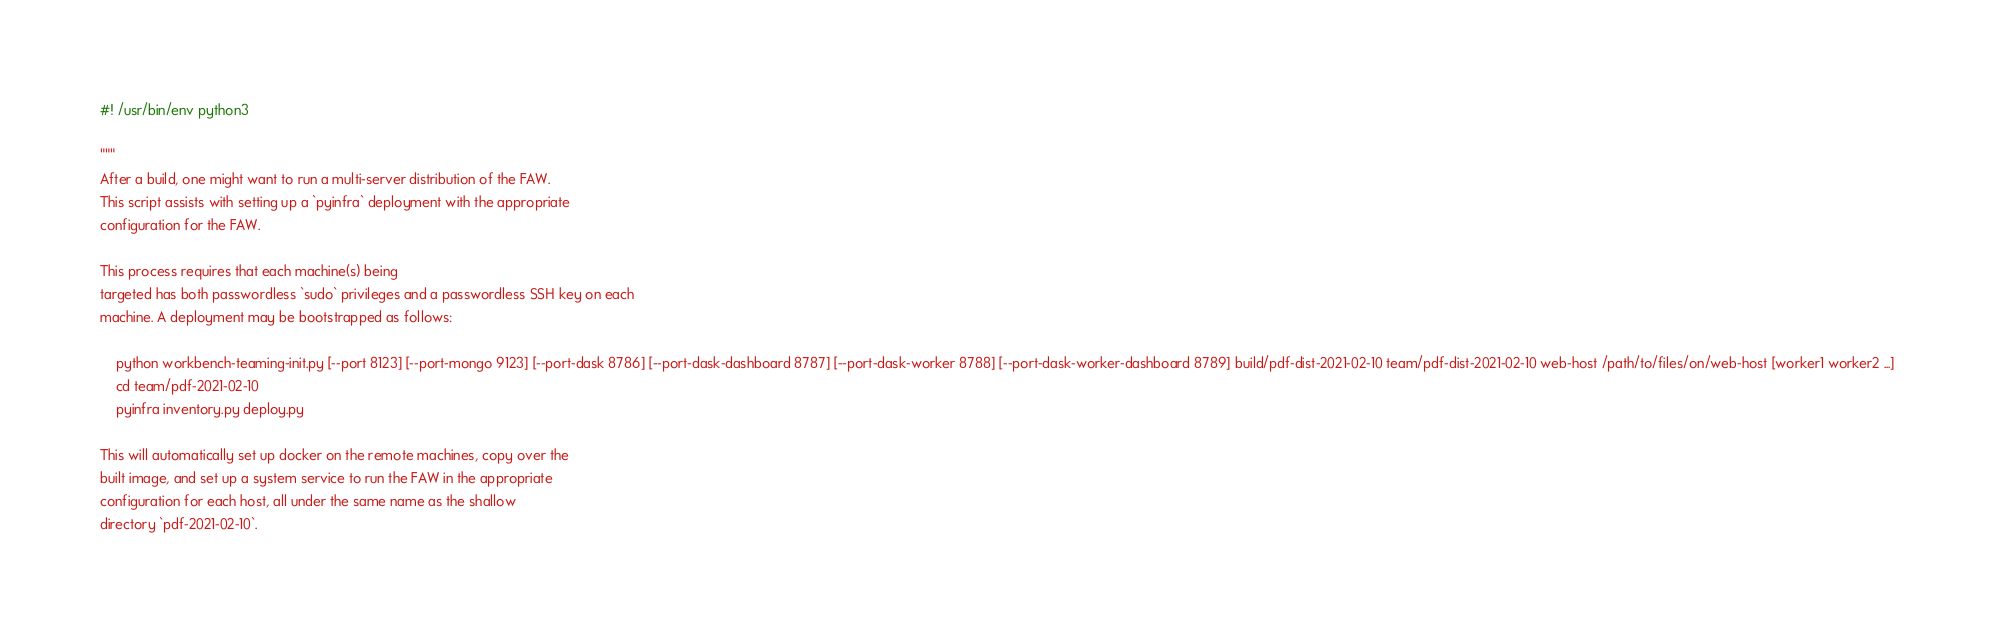Convert code to text. <code><loc_0><loc_0><loc_500><loc_500><_Python_>#! /usr/bin/env python3

"""
After a build, one might want to run a multi-server distribution of the FAW.
This script assists with setting up a `pyinfra` deployment with the appropriate
configuration for the FAW.

This process requires that each machine(s) being
targeted has both passwordless `sudo` privileges and a passwordless SSH key on each
machine. A deployment may be bootstrapped as follows:

    python workbench-teaming-init.py [--port 8123] [--port-mongo 9123] [--port-dask 8786] [--port-dask-dashboard 8787] [--port-dask-worker 8788] [--port-dask-worker-dashboard 8789] build/pdf-dist-2021-02-10 team/pdf-dist-2021-02-10 web-host /path/to/files/on/web-host [worker1 worker2 ...]
    cd team/pdf-2021-02-10
    pyinfra inventory.py deploy.py

This will automatically set up docker on the remote machines, copy over the
built image, and set up a system service to run the FAW in the appropriate
configuration for each host, all under the same name as the shallow
directory `pdf-2021-02-10`.
</code> 